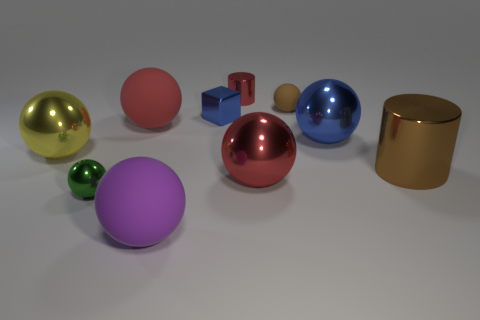What materials appear to be represented by the objects in this image? The objects in the image seem to represent different materials. The shiny gold and silver ones appear metallic, whereas the matte objects might represent plastic or ceramic due to their less reflective surfaces. 